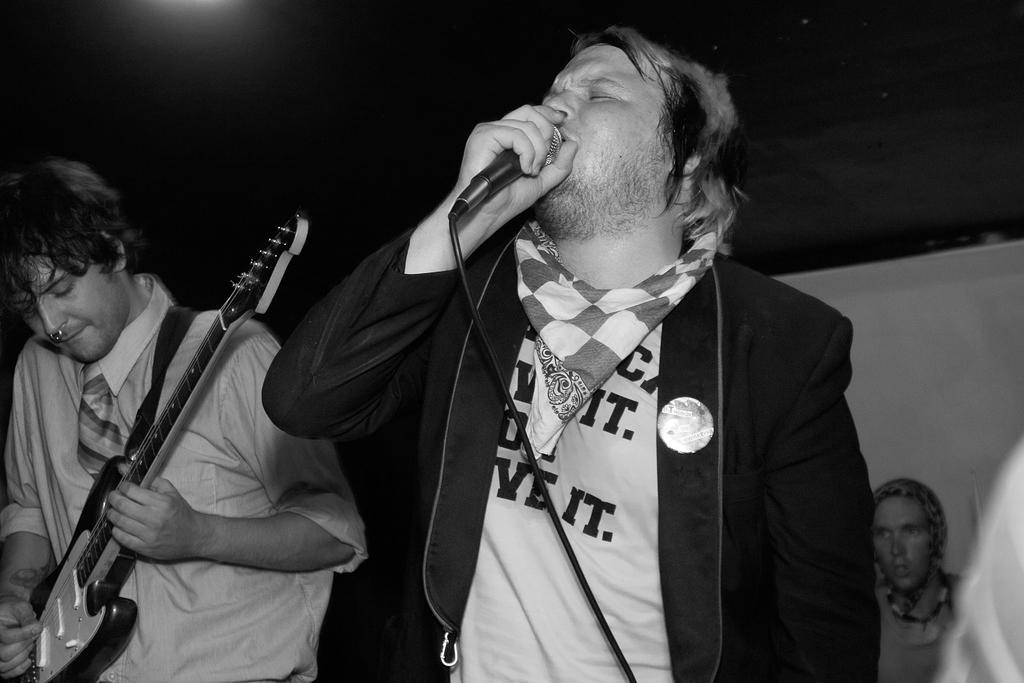Please provide a concise description of this image. In the picture there is a band performing. In the foreground there is a person singing, holding a microphone, he is wearing a black jacket. On the left there is a person playing guitar. On the right there are few people. background is dark. On the left there is a blue color curtain. 